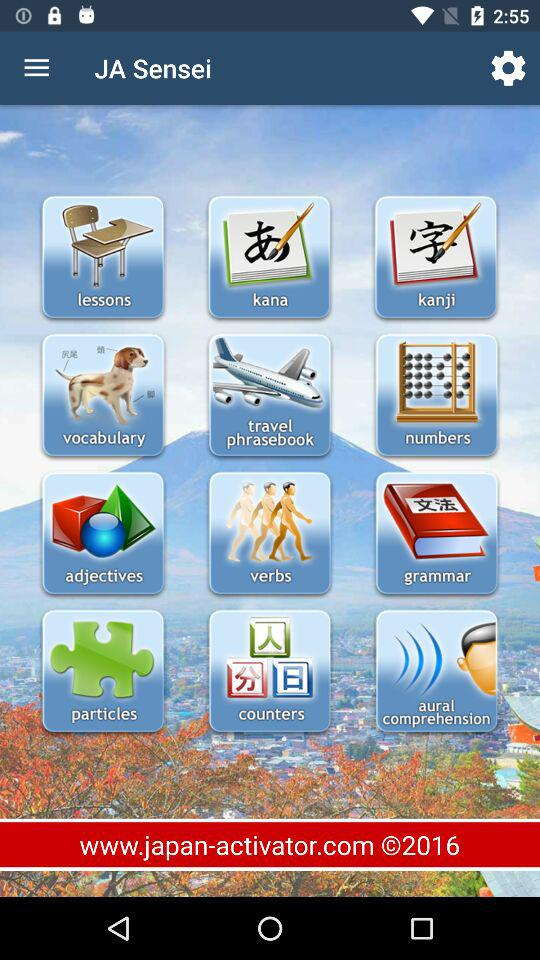What is the help and support email address of this application?
When the provided information is insufficient, respond with <no answer>. <no answer> 